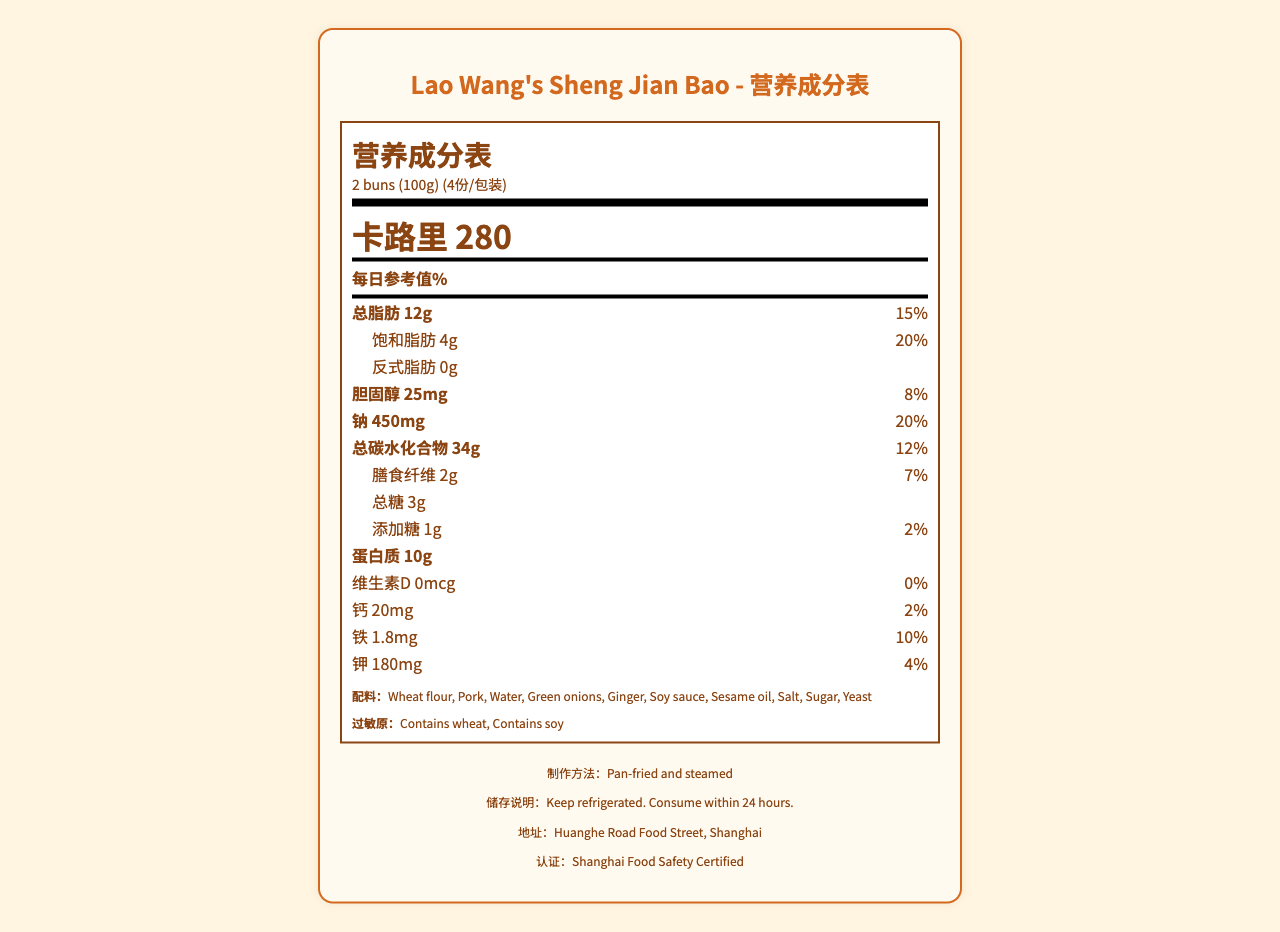what is the serving size for pan-fried pork buns? The serving size is indicated as "2 buns (100g)" in the document.
Answer: 2 buns (100g) how many calories are in one serving of the buns? The document states "卡路里 280" which translates to 280 calories per serving.
Answer: 280 calories what is the daily value percentage of total fat in one serving? The document lists the daily value of total fat as "15%" next to "总脂肪 12g".
Answer: 15% how much sodium is in a single serving? The document specifies "钠 450mg", meaning 450 milligrams of sodium per serving.
Answer: 450mg which ingredients in the buns might cause allergic reactions? The document lists "过敏原：Contains wheat, Contains soy" indicating these are the allergens.
Answer: Wheat, soy which certification does the vendor hold? A. ISO 9001 B. Shanghai Food Safety Certified C. Organic Certification The document mentions "认证：Shanghai Food Safety Certified" as the certification held by the vendor.
Answer: B. Shanghai Food Safety Certified how much protein is in a single serving of the buns? A. 8g B. 10g C. 12g D. 15g The document lists the protein content as "蛋白质 10g" for one serving.
Answer: B. 10g is there any vitamin D in the buns? Yes or No The document shows "维生素D 0mcg", indicating that there is no vitamin D in the buns.
Answer: No provide a summary of the Nutrition Facts Label This summary encapsulates the main nutritional details, preparation and storage instructions, and vendor information from the document.
Answer: The document is a Nutrition Facts Label for Lao Wang's Sheng Jian Bao, a pan-fried and steamed pork bun popular in Shanghai. It includes nutritional information per serving size of 2 buns (100g) such as 280 calories, 12g of total fat (15% DV), and 450mg of sodium (20% DV). The label lists all ingredients, potential allergens (wheat and soy), and storage instructions. The vendor is certified by Shanghai Food Safety and located at Huanghe Road Food Street, Shanghai. how many servings are there per container? The document states "servings per container: 4" which means each package contains 4 servings.
Answer: 4 servings what amount of iron is present in one serving and its daily value percentage? The document indicates "铁 1.8mg" and "10%", representing the iron content and its daily value percentage.
Answer: 1.8mg, 10% can I consume these buns immediately after buying? The document mentions the buns should be kept refrigerated and consumed within 24 hours, but it does not specify if they need reheating or any other preparation before consumption.
Answer: Not enough information 